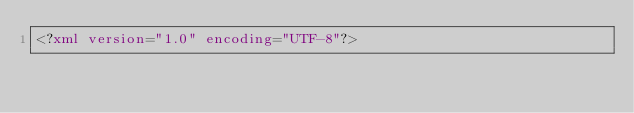Convert code to text. <code><loc_0><loc_0><loc_500><loc_500><_XML_><?xml version="1.0" encoding="UTF-8"?></code> 